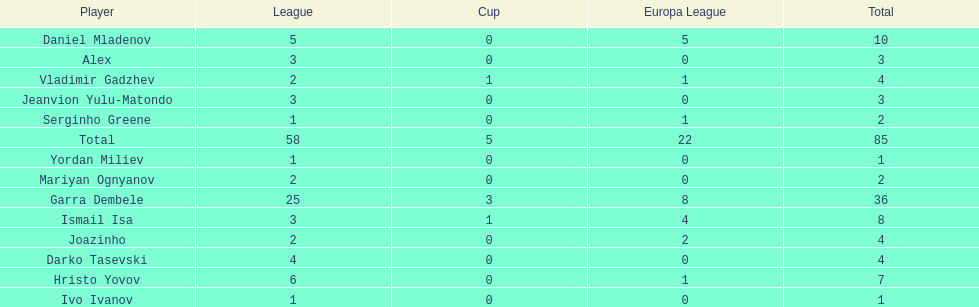Who was the top goalscorer on this team? Garra Dembele. 